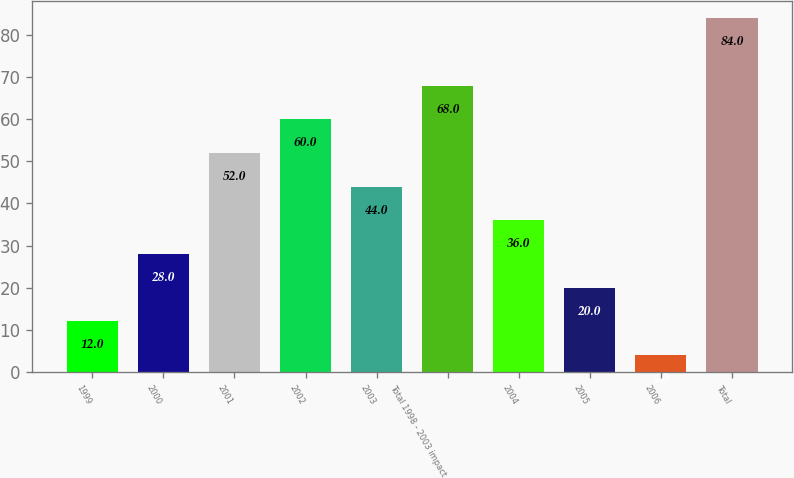<chart> <loc_0><loc_0><loc_500><loc_500><bar_chart><fcel>1999<fcel>2000<fcel>2001<fcel>2002<fcel>2003<fcel>Total 1998 - 2003 impact<fcel>2004<fcel>2005<fcel>2006<fcel>Total<nl><fcel>12<fcel>28<fcel>52<fcel>60<fcel>44<fcel>68<fcel>36<fcel>20<fcel>4<fcel>84<nl></chart> 